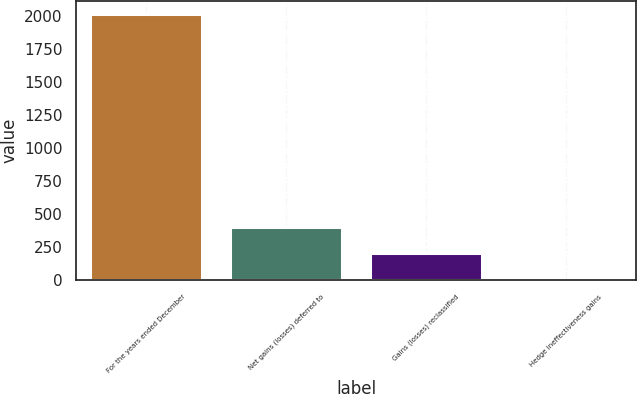Convert chart. <chart><loc_0><loc_0><loc_500><loc_500><bar_chart><fcel>For the years ended December<fcel>Net gains (losses) deferred to<fcel>Gains (losses) reclassified<fcel>Hedge ineffectiveness gains<nl><fcel>2013<fcel>405.16<fcel>204.18<fcel>3.2<nl></chart> 